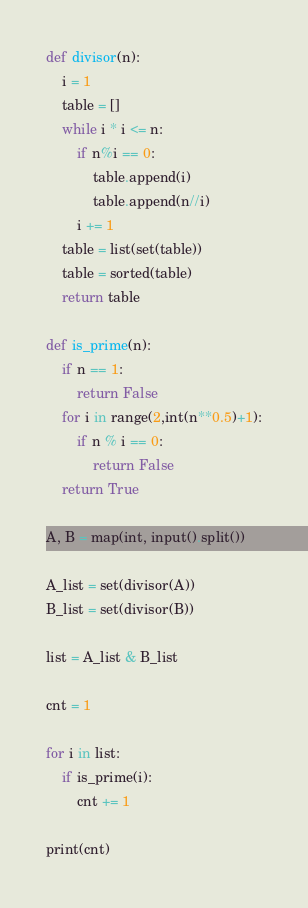<code> <loc_0><loc_0><loc_500><loc_500><_Python_>def divisor(n): 
    i = 1
    table = []
    while i * i <= n:
        if n%i == 0:
            table.append(i)
            table.append(n//i)
        i += 1
    table = list(set(table))
    table = sorted(table)
    return table

def is_prime(n):
    if n == 1:
        return False
    for i in range(2,int(n**0.5)+1):
        if n % i == 0:
            return False
    return True

A, B = map(int, input().split())

A_list = set(divisor(A))
B_list = set(divisor(B))

list = A_list & B_list

cnt = 1

for i in list:
    if is_prime(i):
        cnt += 1

print(cnt)</code> 